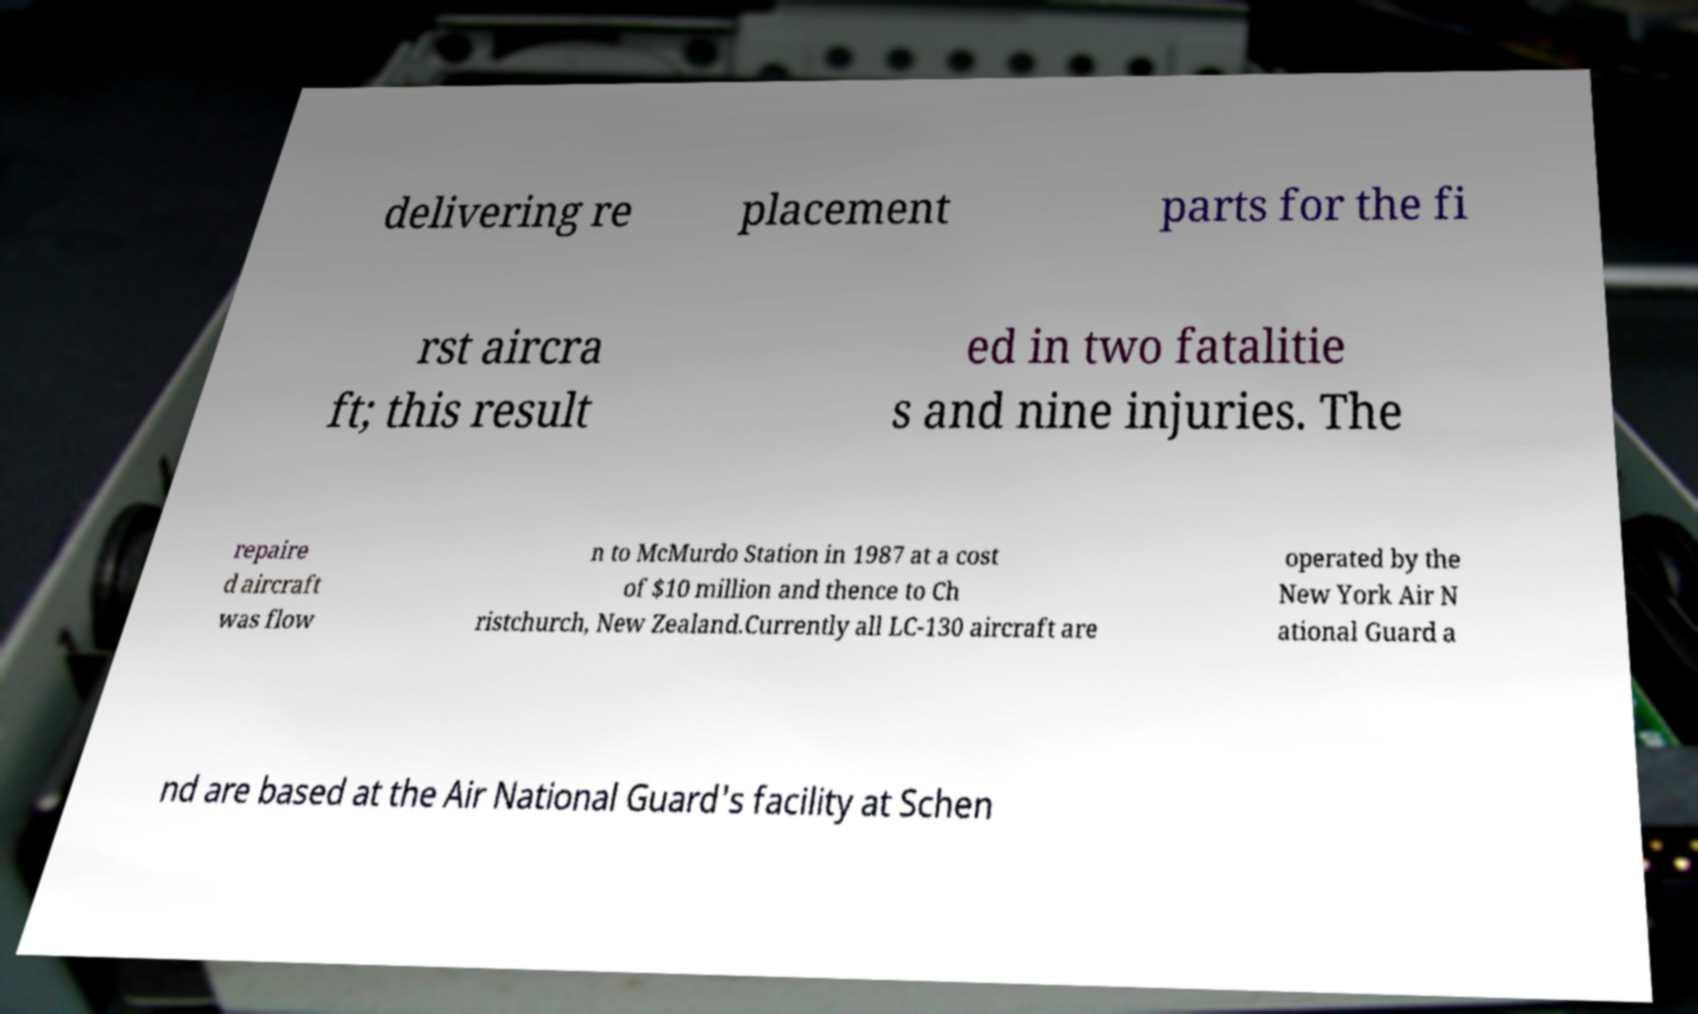There's text embedded in this image that I need extracted. Can you transcribe it verbatim? delivering re placement parts for the fi rst aircra ft; this result ed in two fatalitie s and nine injuries. The repaire d aircraft was flow n to McMurdo Station in 1987 at a cost of $10 million and thence to Ch ristchurch, New Zealand.Currently all LC-130 aircraft are operated by the New York Air N ational Guard a nd are based at the Air National Guard's facility at Schen 